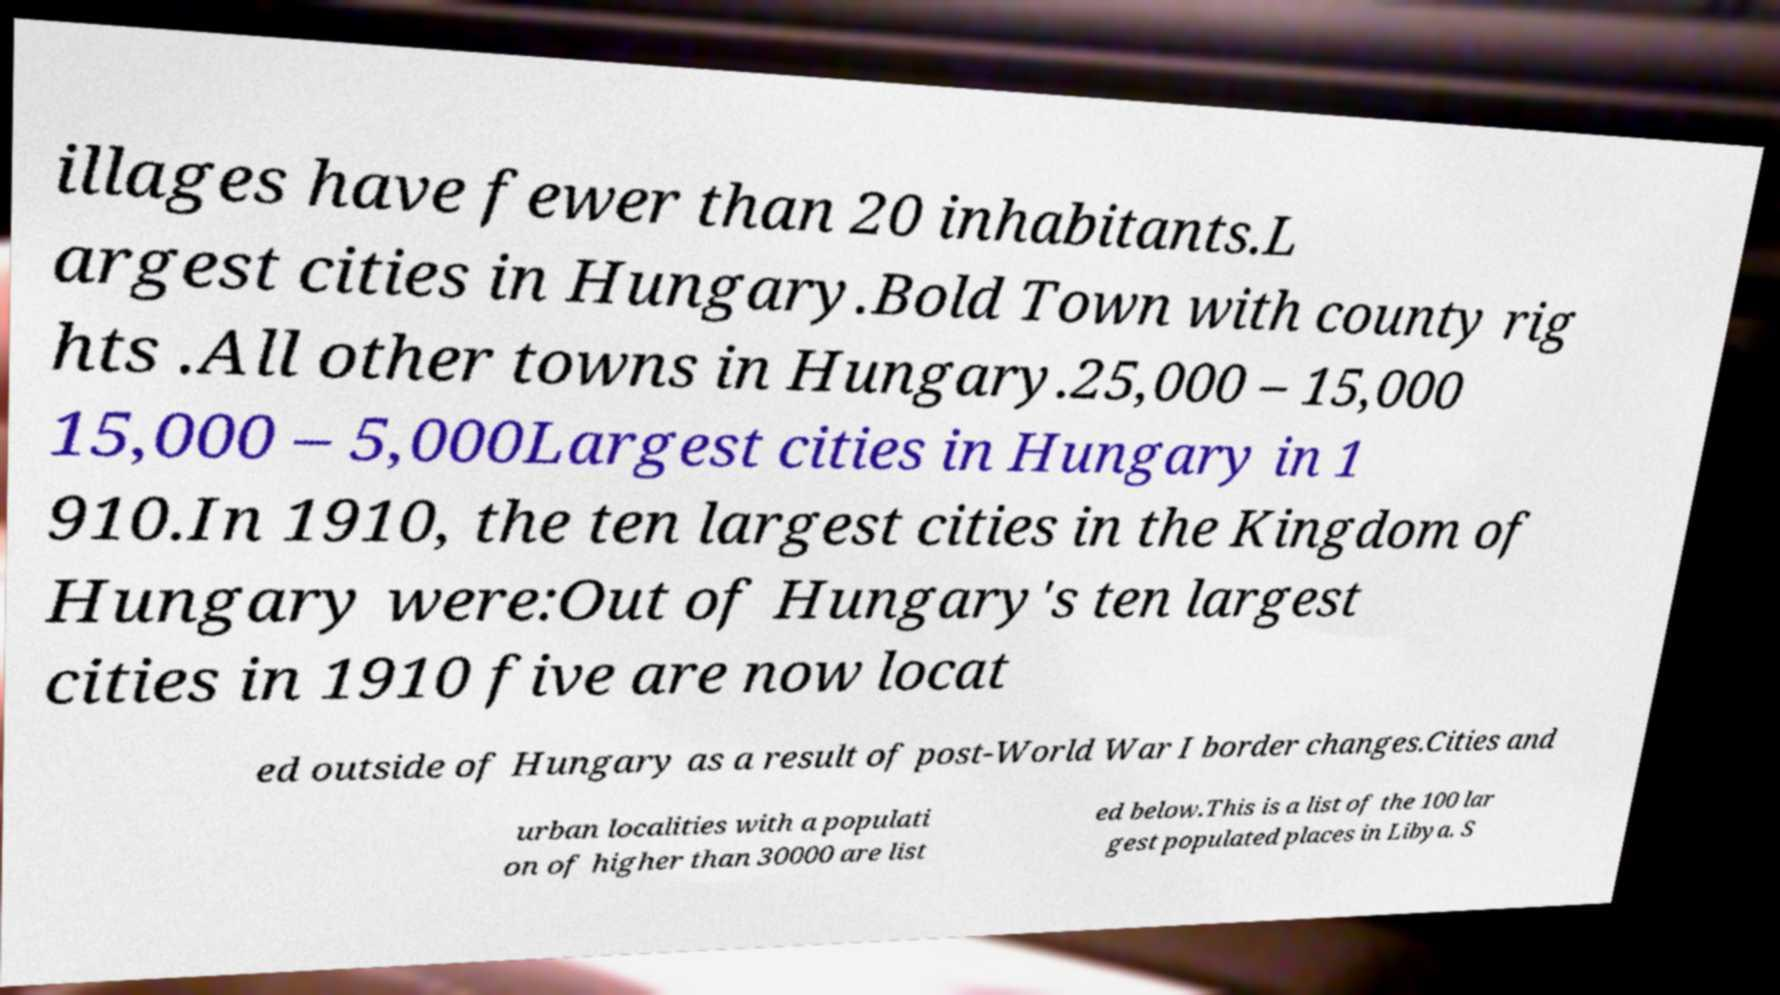For documentation purposes, I need the text within this image transcribed. Could you provide that? illages have fewer than 20 inhabitants.L argest cities in Hungary.Bold Town with county rig hts .All other towns in Hungary.25,000 – 15,000 15,000 – 5,000Largest cities in Hungary in 1 910.In 1910, the ten largest cities in the Kingdom of Hungary were:Out of Hungary's ten largest cities in 1910 five are now locat ed outside of Hungary as a result of post-World War I border changes.Cities and urban localities with a populati on of higher than 30000 are list ed below.This is a list of the 100 lar gest populated places in Libya. S 